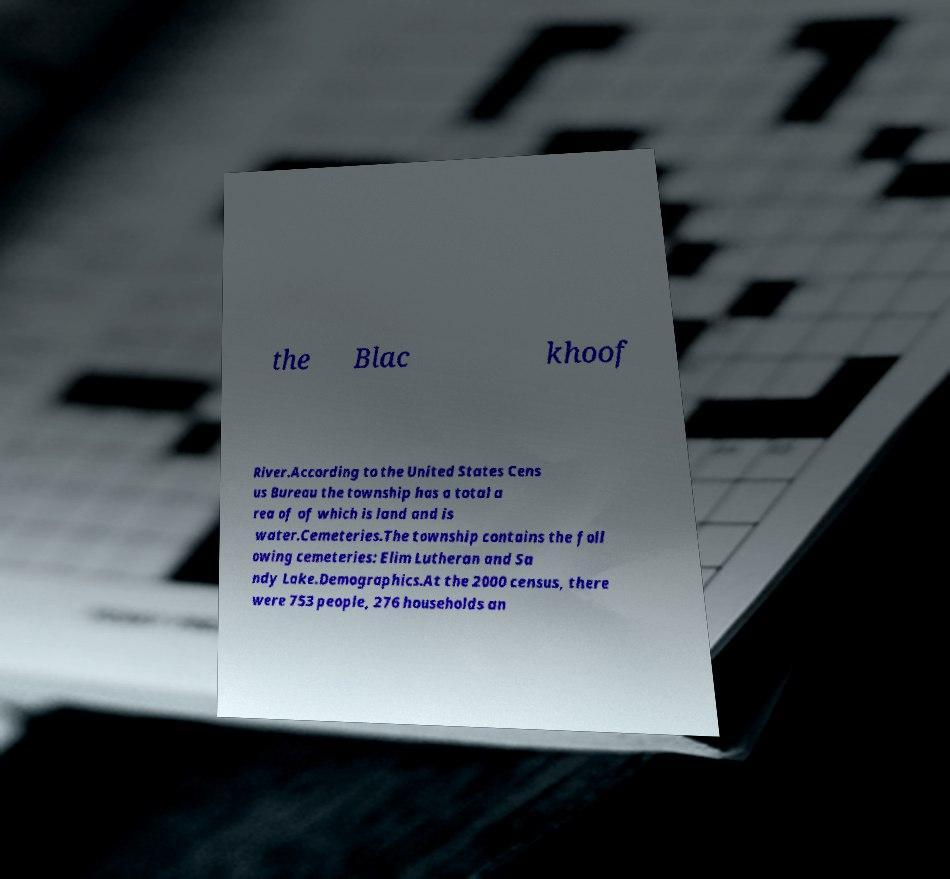Could you extract and type out the text from this image? the Blac khoof River.According to the United States Cens us Bureau the township has a total a rea of of which is land and is water.Cemeteries.The township contains the foll owing cemeteries: Elim Lutheran and Sa ndy Lake.Demographics.At the 2000 census, there were 753 people, 276 households an 